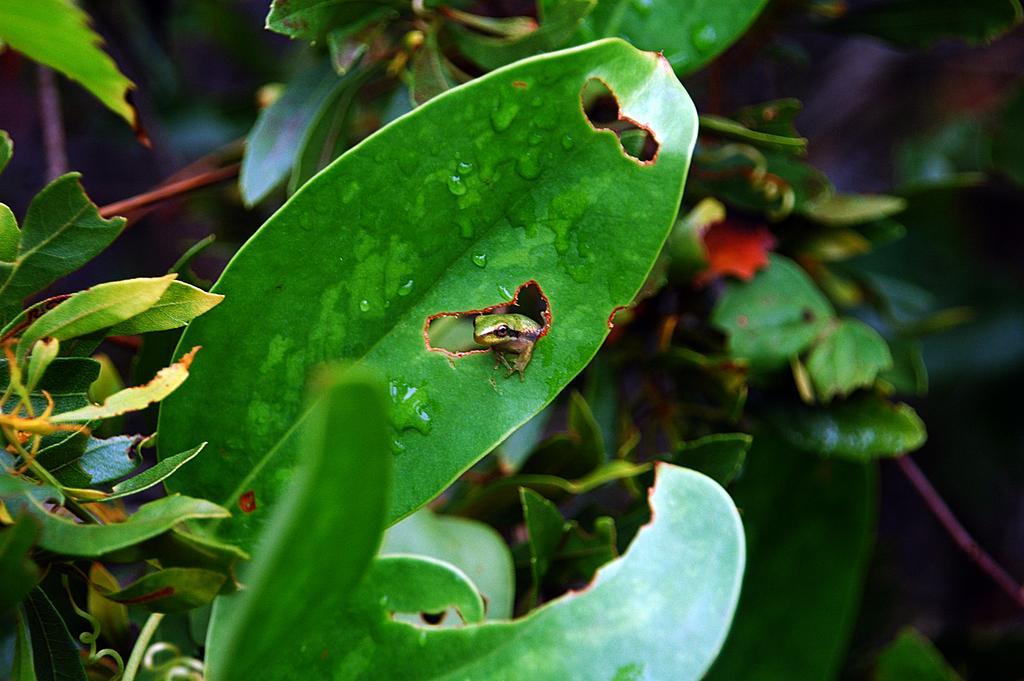Describe this image in one or two sentences. In the center of the image we can see one leaf. On the leaf,we can see one reptile,which is in green color. In the background we can see plants. 